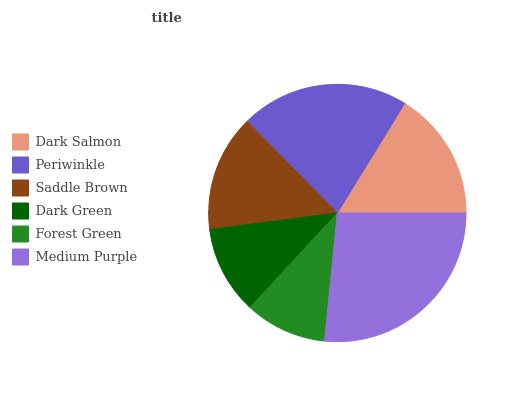Is Forest Green the minimum?
Answer yes or no. Yes. Is Medium Purple the maximum?
Answer yes or no. Yes. Is Periwinkle the minimum?
Answer yes or no. No. Is Periwinkle the maximum?
Answer yes or no. No. Is Periwinkle greater than Dark Salmon?
Answer yes or no. Yes. Is Dark Salmon less than Periwinkle?
Answer yes or no. Yes. Is Dark Salmon greater than Periwinkle?
Answer yes or no. No. Is Periwinkle less than Dark Salmon?
Answer yes or no. No. Is Dark Salmon the high median?
Answer yes or no. Yes. Is Saddle Brown the low median?
Answer yes or no. Yes. Is Periwinkle the high median?
Answer yes or no. No. Is Periwinkle the low median?
Answer yes or no. No. 